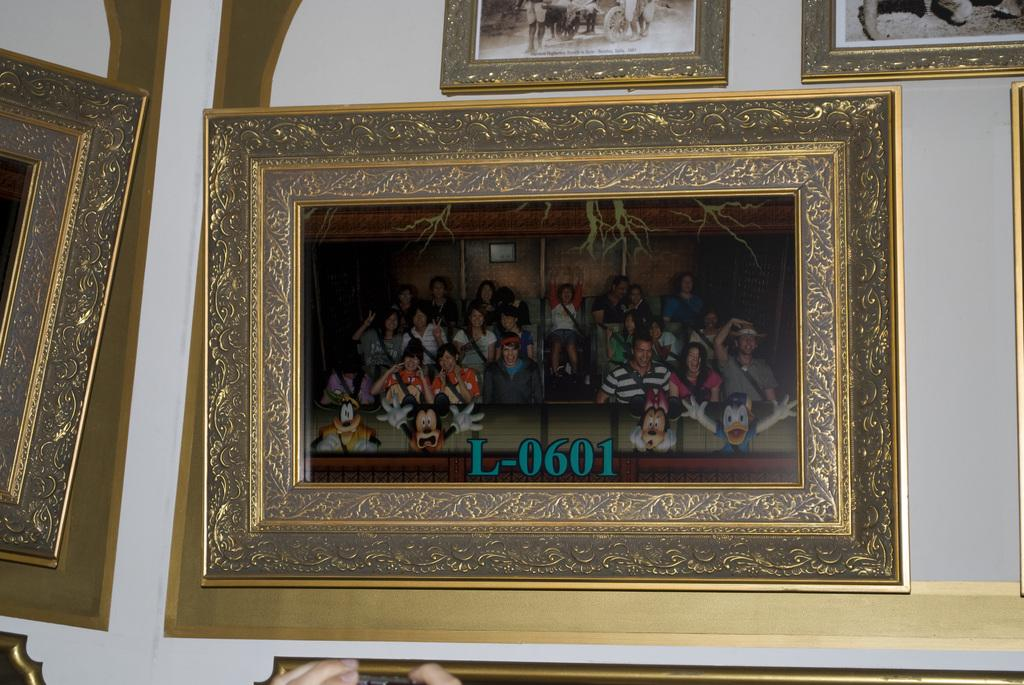Provide a one-sentence caption for the provided image. several framed photos on wall, one labeled L-0601. 